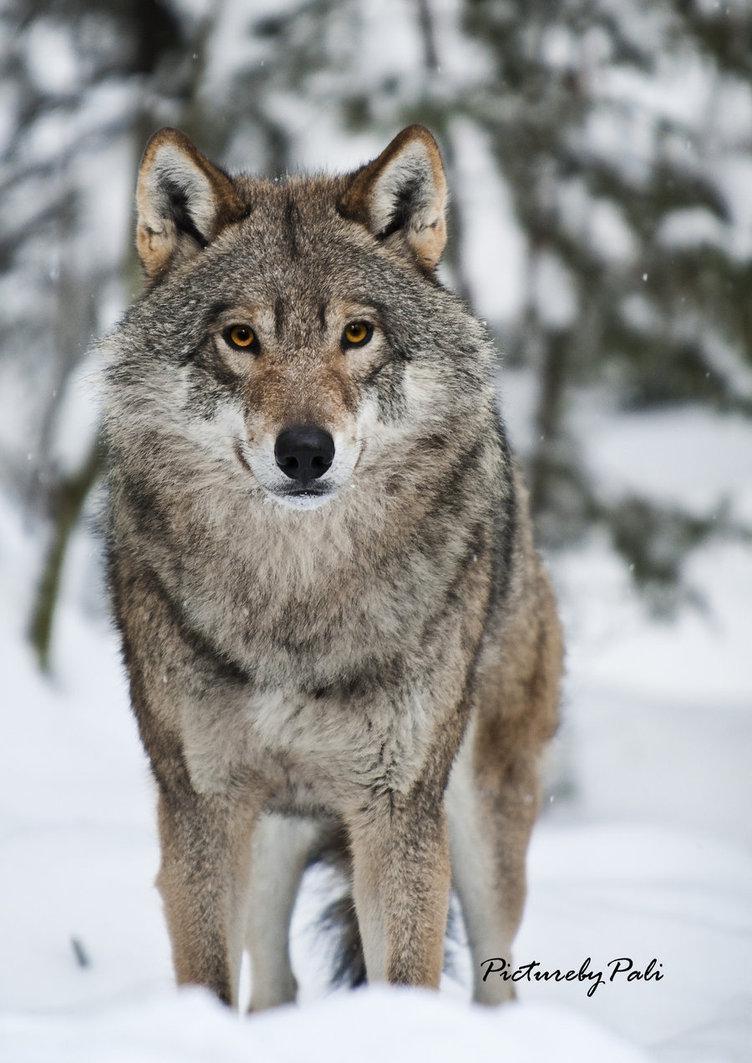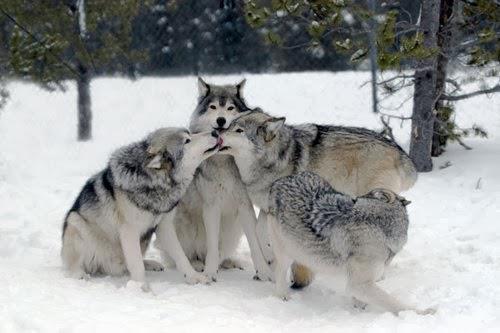The first image is the image on the left, the second image is the image on the right. For the images shown, is this caption "The right image contains at least four wolves positioned close together in a snow-covered scene." true? Answer yes or no. Yes. The first image is the image on the left, the second image is the image on the right. Analyze the images presented: Is the assertion "There are two wolves" valid? Answer yes or no. No. 